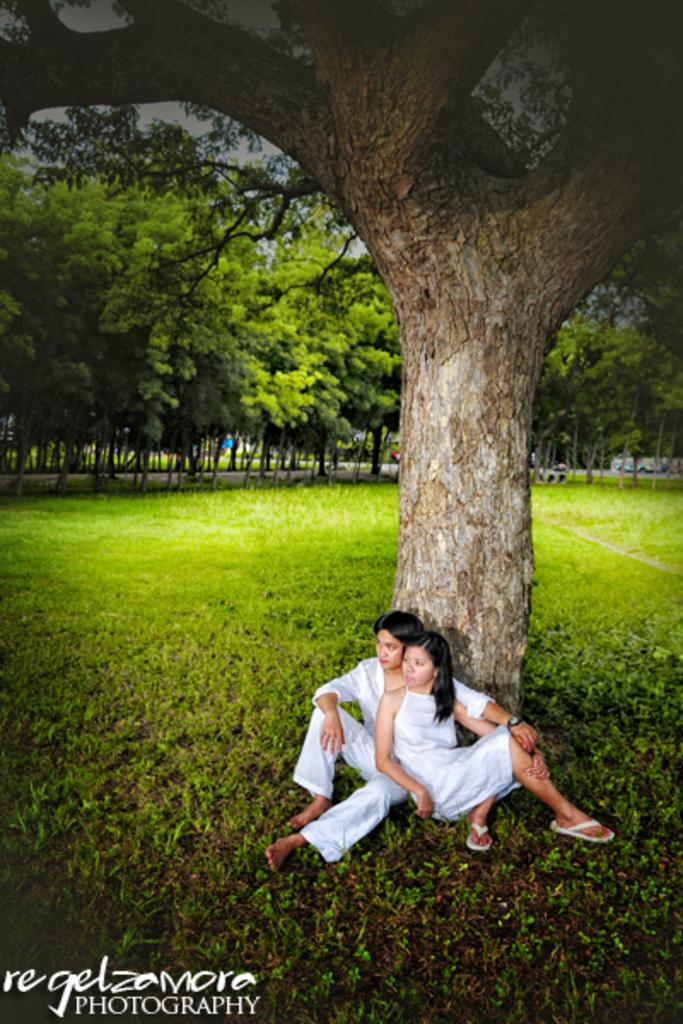How many people are sitting in the image? There are two people sitting beside a tree trunk in the image. What type of vegetation is visible in the image? There are trees and grass visible in the image. Can you describe the background of the image? There appears to be a vehicle in the background of the image. How many apples are hanging from the tree in the image? There are no apples visible in the image; only trees and grass are present. 